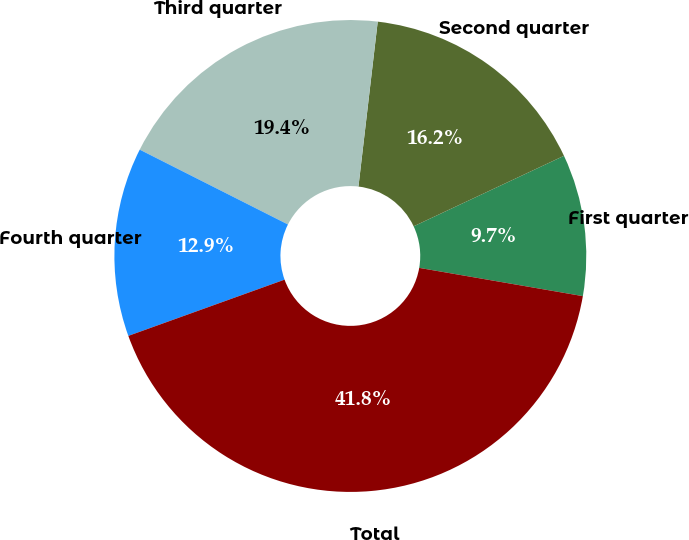Convert chart. <chart><loc_0><loc_0><loc_500><loc_500><pie_chart><fcel>First quarter<fcel>Second quarter<fcel>Third quarter<fcel>Fourth quarter<fcel>Total<nl><fcel>9.7%<fcel>16.17%<fcel>19.41%<fcel>12.94%<fcel>41.78%<nl></chart> 